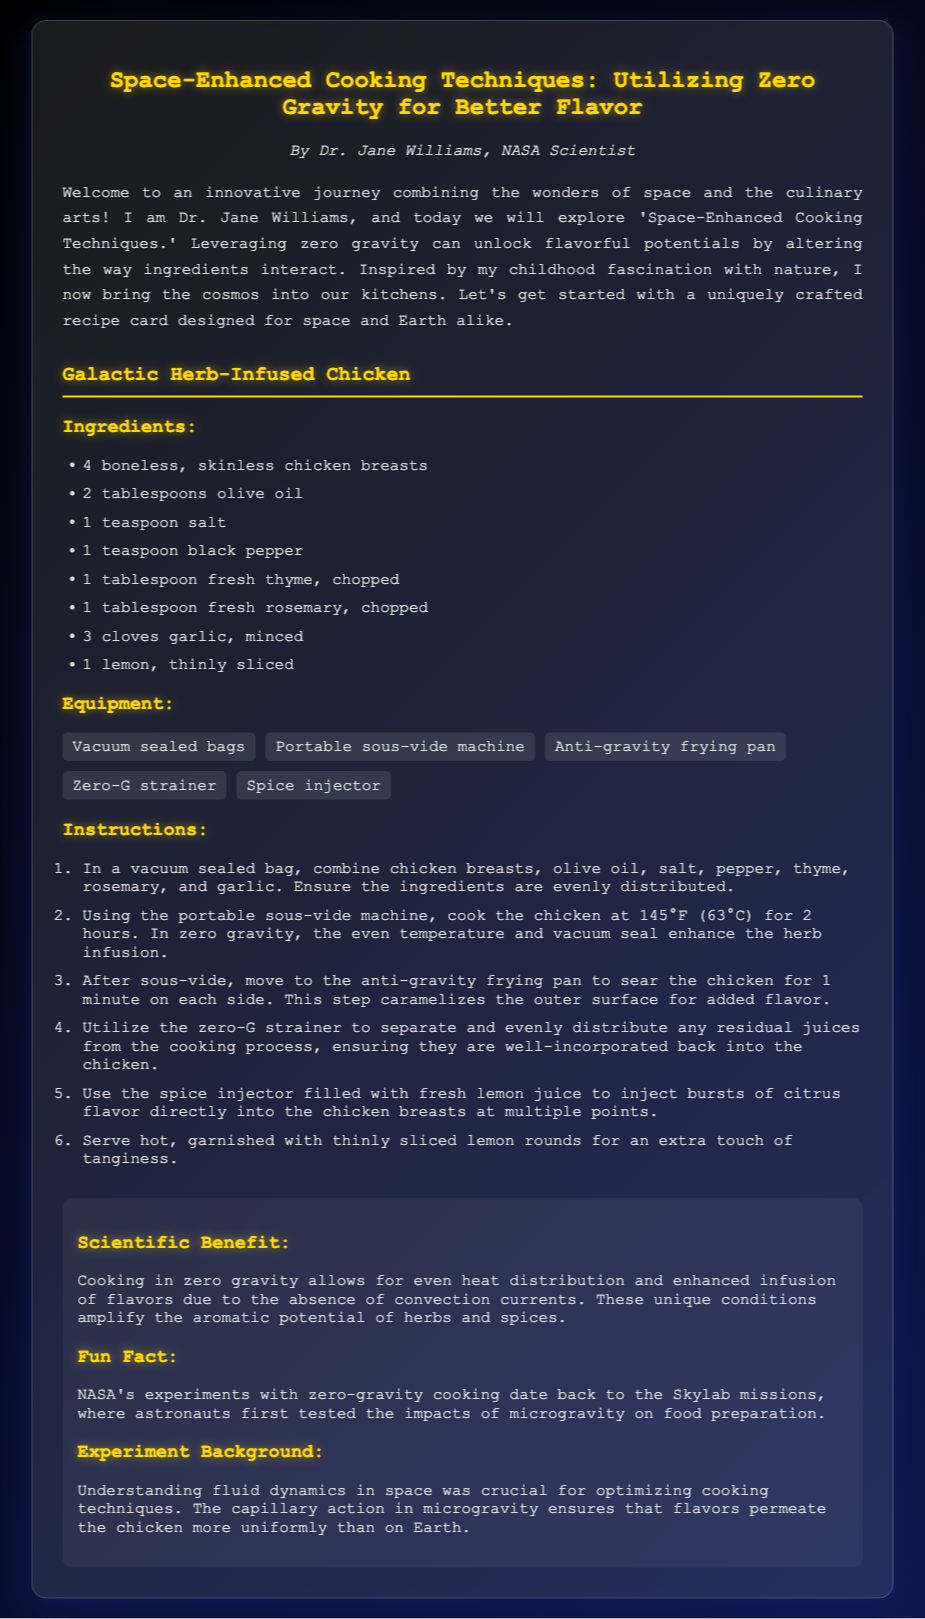What is the title of the recipe card? The title of the recipe card is prominently displayed at the top of the document.
Answer: Space-Enhanced Cooking Techniques: Utilizing Zero Gravity for Better Flavor Who is the author of the recipe card? The author's name is mentioned below the title in the document.
Answer: Dr. Jane Williams What is the cooking temperature for the chicken? The document specifies the temperature in the instructions for cooking the chicken.
Answer: 145°F (63°C) How long should the chicken be cooked using the sous-vide machine? The cooking time is stated in the instructions for the sous-vide process.
Answer: 2 hours What is a key scientific benefit of cooking in zero gravity? The document explains a specific benefit related to flavor enhancement due to the cooking environment.
Answer: Even heat distribution How many cloves of garlic are used in the recipe? The ingredient list clearly mentions the quantity of garlic needed.
Answer: 3 cloves What equipment is used to infuse chicken with lemon juice? The document mentions a specific tool used for injecting lemon juice into the chicken.
Answer: Spice injector What does the anti-gravity frying pan do? The functionality of the frying pan is described in the cooking instructions.
Answer: Sear the chicken What is the primary herb used in the recipe? The ingredient list includes a key herb that is used in the chicken recipe.
Answer: Thyme 